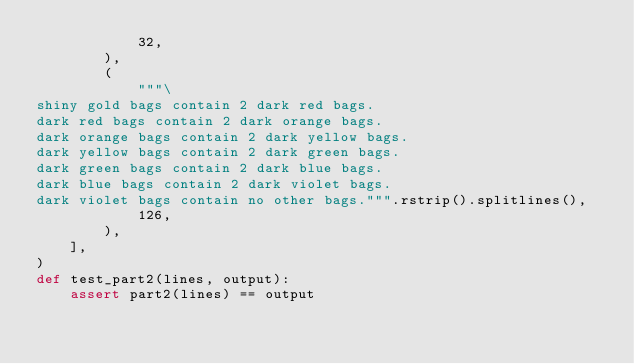<code> <loc_0><loc_0><loc_500><loc_500><_Python_>            32,
        ),
        (
            """\
shiny gold bags contain 2 dark red bags.
dark red bags contain 2 dark orange bags.
dark orange bags contain 2 dark yellow bags.
dark yellow bags contain 2 dark green bags.
dark green bags contain 2 dark blue bags.
dark blue bags contain 2 dark violet bags.
dark violet bags contain no other bags.""".rstrip().splitlines(),
            126,
        ),
    ],
)
def test_part2(lines, output):
    assert part2(lines) == output
</code> 